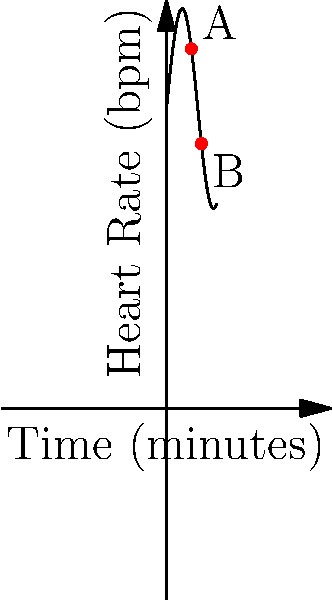As a paramedic attending to a patient, you observe their heart rate changing over time as shown in the graph. Calculate the average rate of change in the patient's heart rate between points A and B. To calculate the average rate of change between two points, we use the formula:

$$ \text{Average rate of change} = \frac{\text{Change in y}}{\text{Change in x}} = \frac{y_2 - y_1}{x_2 - x_1} $$

1. Identify the coordinates of points A and B:
   Point A: (5, f(5))
   Point B: (7, f(7))

2. Calculate f(5) and f(7):
   $f(x) = 60 + 20\sin(x/2)$
   $f(5) = 60 + 20\sin(5/2) \approx 74.1$ bpm
   $f(7) = 60 + 20\sin(7/2) \approx 65.8$ bpm

3. Apply the formula:
   $$ \text{Average rate of change} = \frac{65.8 - 74.1}{7 - 5} = \frac{-8.3}{2} = -4.15 $$

4. Interpret the result: The average rate of change is approximately -4.15 bpm per minute.
Answer: -4.15 bpm/min 